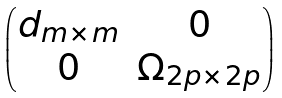Convert formula to latex. <formula><loc_0><loc_0><loc_500><loc_500>\begin{pmatrix} \i d _ { m \times m } & 0 \\ 0 & \Omega _ { 2 p \times 2 p } \end{pmatrix}</formula> 